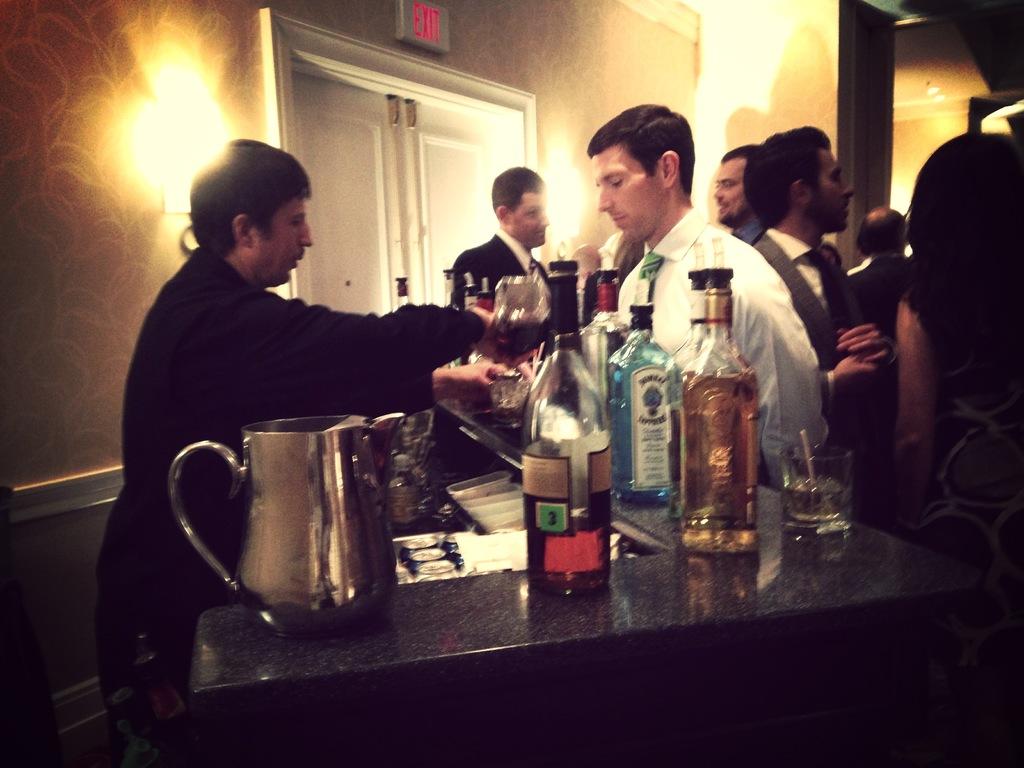Is the red sign above the door and exit sign?
Your answer should be compact. Yes. 